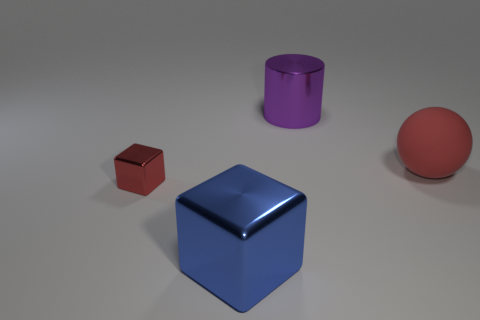What is the color of the largest object in the image? The largest object in the image is the blue cube. It has a shiny surface which reflects some of the environment, making it visually striking. 